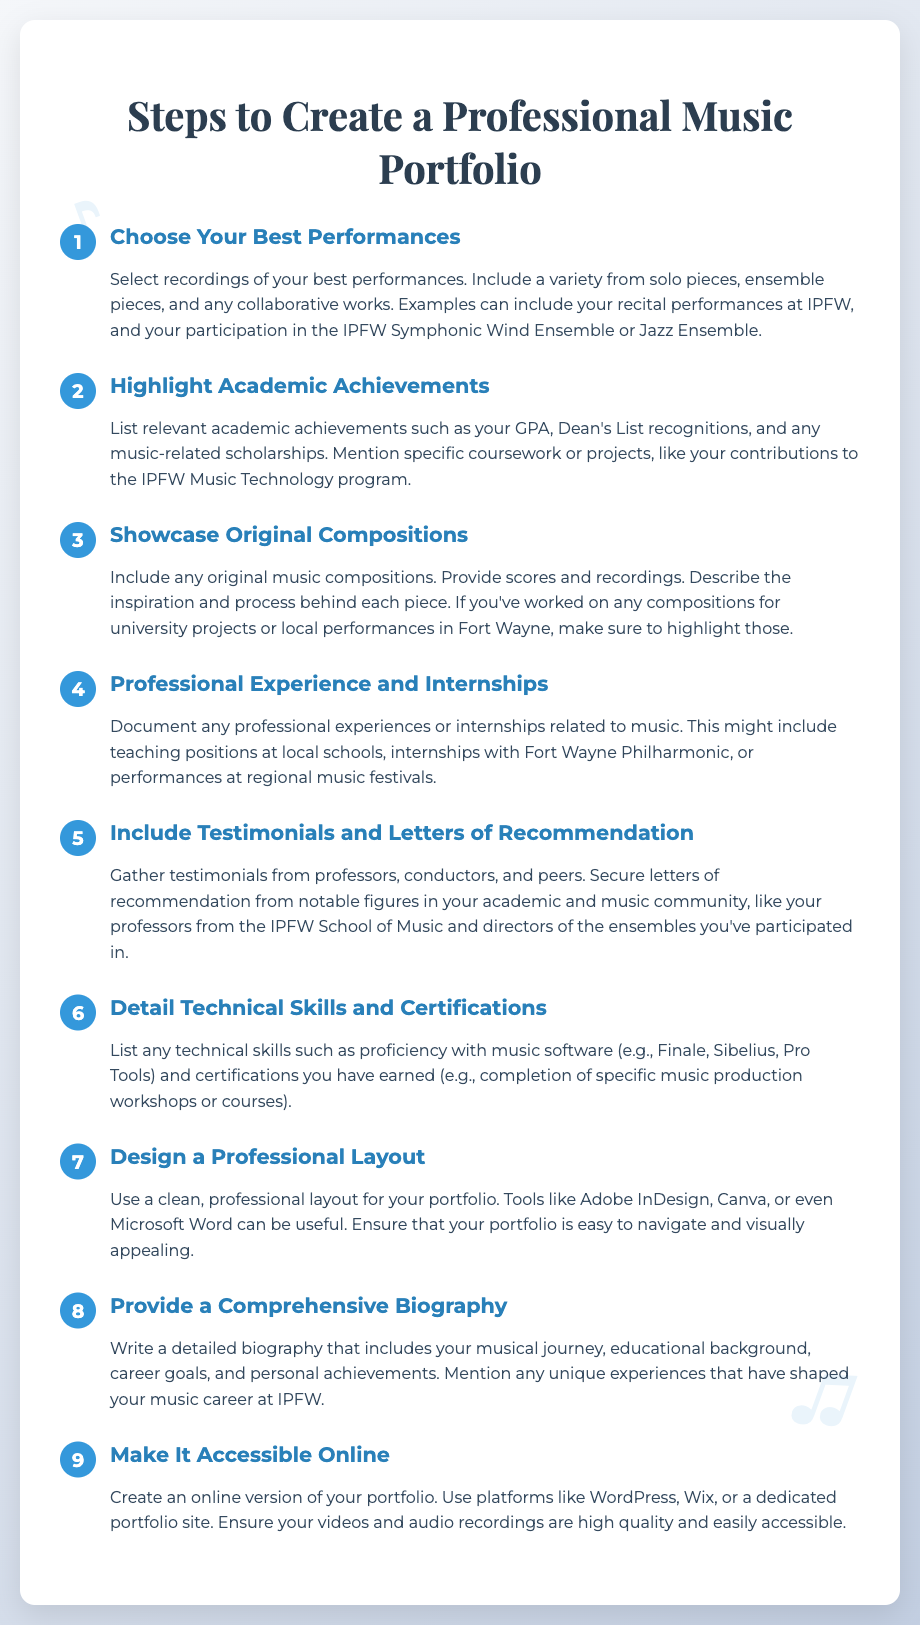What is the first step to create a professional music portfolio? The first step mentioned in the document is "Choose Your Best Performances," which involves selecting recordings of your best performances.
Answer: Choose Your Best Performances What should you include when showcasing original compositions? When showcasing original compositions, you should include scores and recordings, as well as describe the inspiration and process behind each piece.
Answer: Scores and recordings How many steps are there to create a professional music portfolio? The document outlines a total of nine steps involved in creating a professional music portfolio.
Answer: Nine Which software skills are mentioned in the document? The document mentions proficiency with music software such as Finale, Sibelius, and Pro Tools as important technical skills.
Answer: Finale, Sibelius, Pro Tools What type of experiences should be documented under professional experience? The document suggests documenting teaching positions, internships, and performances related to music as professional experiences.
Answer: Teaching positions, internships, performances What is a key element in designing your portfolio? A key element in designing your portfolio is using a clean, professional layout that is easy to navigate and visually appealing.
Answer: Clean, professional layout Which elements can enhance the credibility of your portfolio? Gathering testimonials and securing letters of recommendation from professors and notable figures in the music community can enhance credibility.
Answer: Testimonials and letters of recommendation What should your biography include? Your biography should include your musical journey, educational background, career goals, and personal achievements along with unique experiences.
Answer: Musical journey, educational background, career goals, personal achievements What online platforms can be used to make your portfolio accessible? The document suggests using platforms like WordPress, Wix, or a dedicated portfolio site to make your portfolio accessible online.
Answer: WordPress, Wix, dedicated portfolio site 